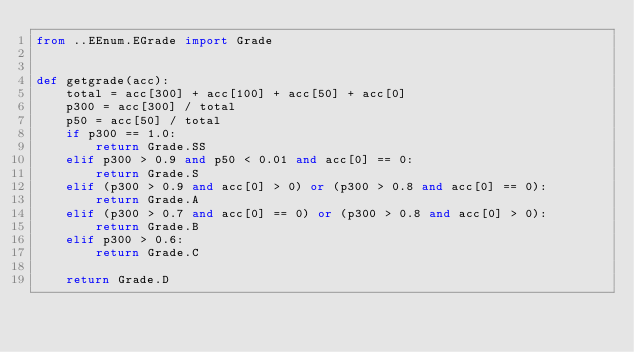<code> <loc_0><loc_0><loc_500><loc_500><_Python_>from ..EEnum.EGrade import Grade


def getgrade(acc):
	total = acc[300] + acc[100] + acc[50] + acc[0]
	p300 = acc[300] / total
	p50 = acc[50] / total
	if p300 == 1.0:
		return Grade.SS
	elif p300 > 0.9 and p50 < 0.01 and acc[0] == 0:
		return Grade.S
	elif (p300 > 0.9 and acc[0] > 0) or (p300 > 0.8 and acc[0] == 0):
		return Grade.A
	elif (p300 > 0.7 and acc[0] == 0) or (p300 > 0.8 and acc[0] > 0):
		return Grade.B
	elif p300 > 0.6:
		return Grade.C

	return Grade.D
</code> 